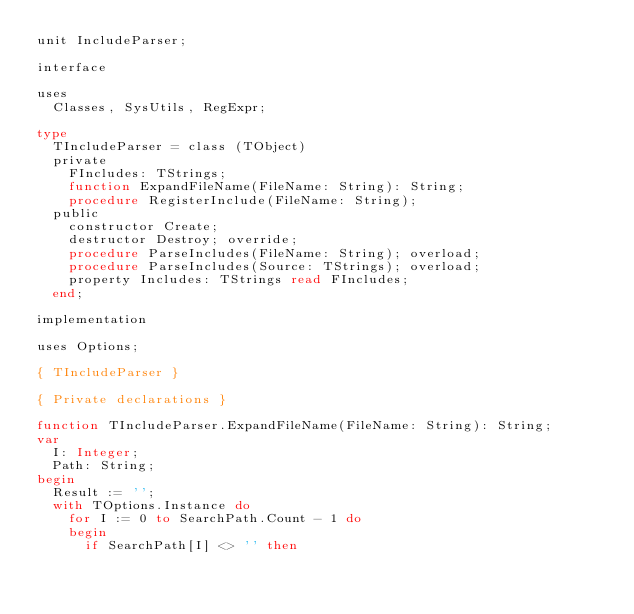Convert code to text. <code><loc_0><loc_0><loc_500><loc_500><_Pascal_>unit IncludeParser;

interface

uses
  Classes, SysUtils, RegExpr;

type
  TIncludeParser = class (TObject)
  private
    FIncludes: TStrings;
    function ExpandFileName(FileName: String): String;
    procedure RegisterInclude(FileName: String);
  public
    constructor Create;
    destructor Destroy; override;
    procedure ParseIncludes(FileName: String); overload;
    procedure ParseIncludes(Source: TStrings); overload;
    property Includes: TStrings read FIncludes;
  end;

implementation

uses Options;

{ TIncludeParser }

{ Private declarations }

function TIncludeParser.ExpandFileName(FileName: String): String;
var
  I: Integer;
  Path: String;
begin
  Result := '';
  with TOptions.Instance do
    for I := 0 to SearchPath.Count - 1 do
    begin
      if SearchPath[I] <> '' then</code> 